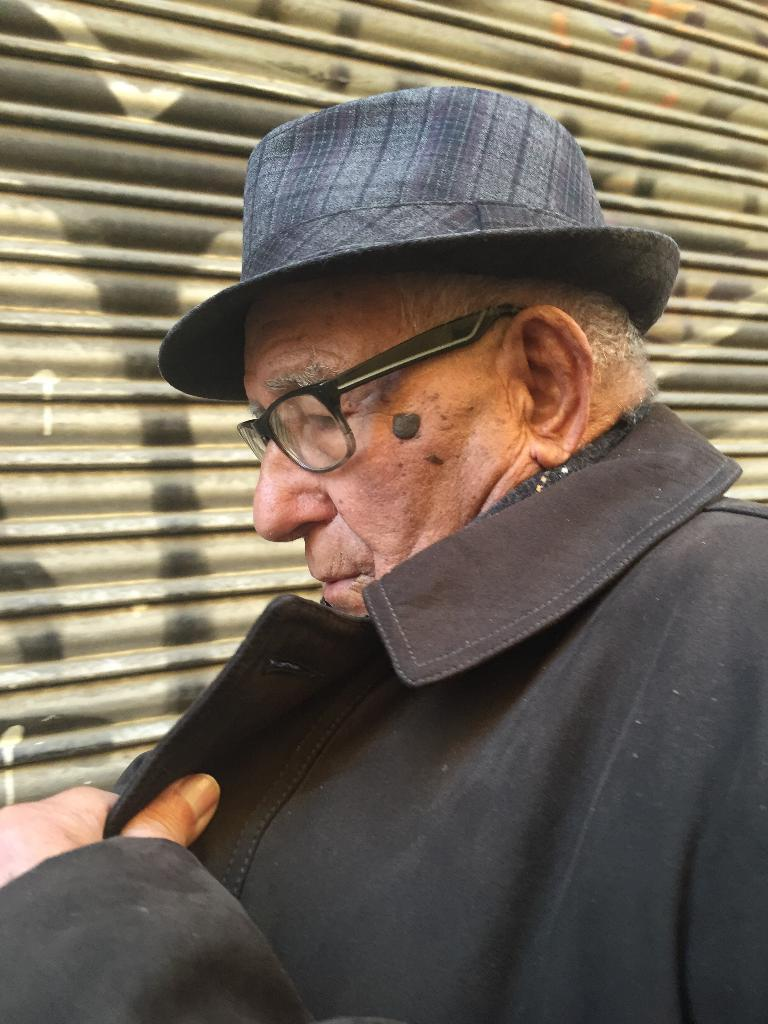What is the main subject of the image? The main subject of the image is a man. What is the man wearing on his upper body? The man is wearing a jacket. What type of eyewear is the man wearing? The man is wearing specs. What headgear is the man wearing? The man is wearing a hat. What color is the man's jacket? The jacket is black in color. What is located behind the man in the image? There is a shutter behind the man. What type of vegetable is the man holding in the image? There is no vegetable present in the image; the man is not holding any vegetable. What is the man using to calculate the distance between two points in the image? There is no calculator present in the image, and the man is not performing any calculations. 